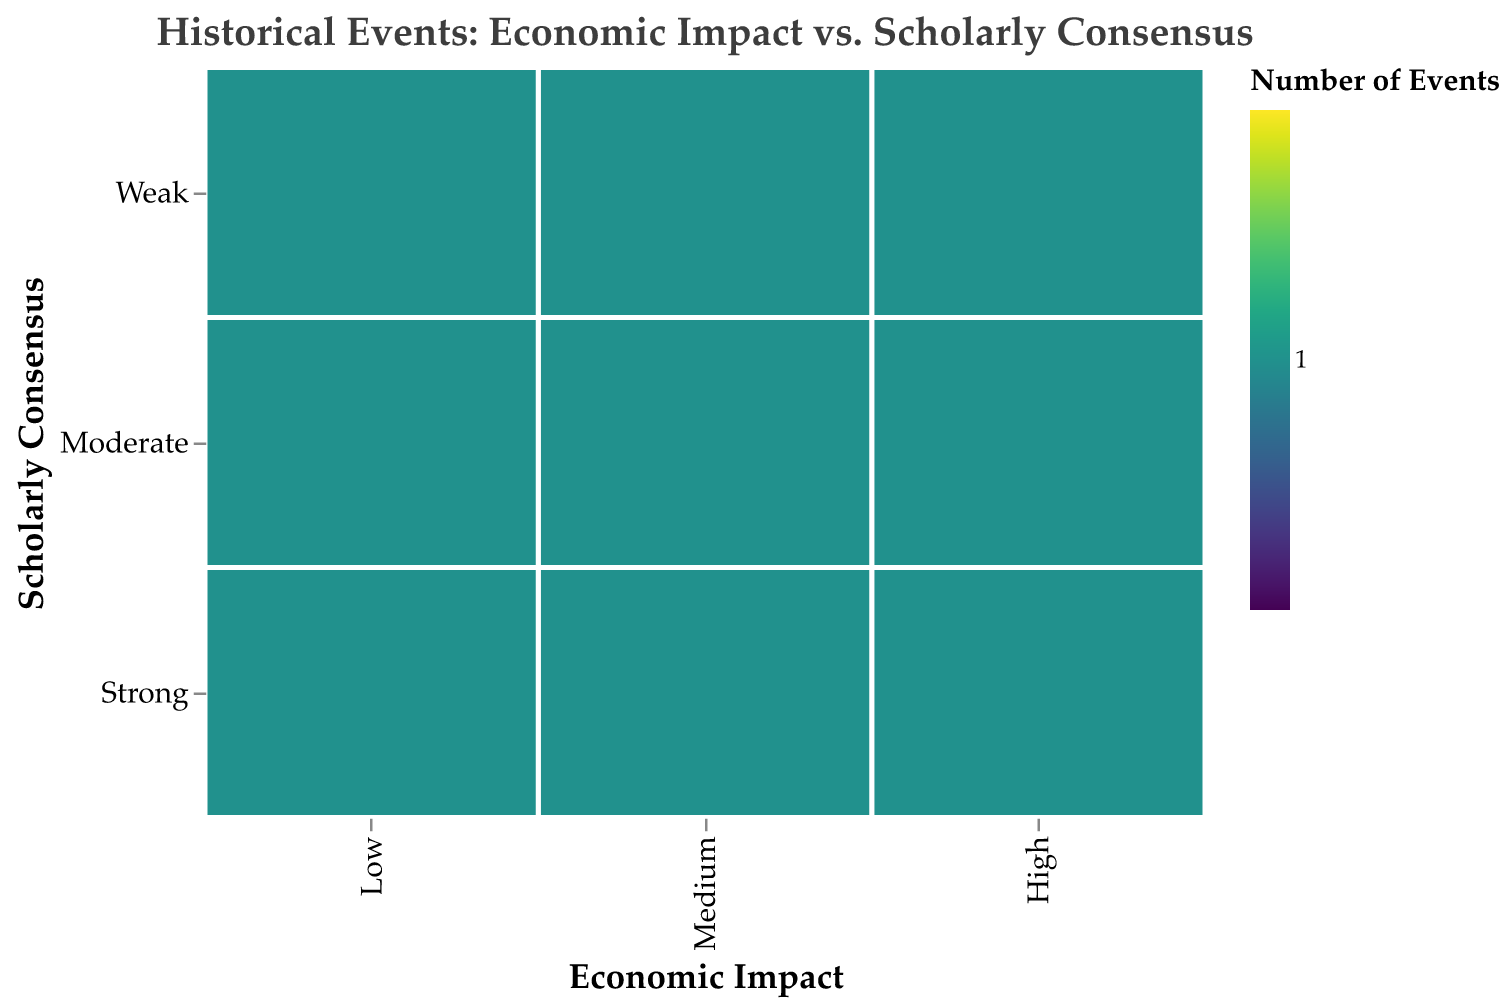What is the title of the figure? The title is usually located at the top of the figure and reads "Historical Events: Economic Impact vs. Scholarly Consensus" in this case.
Answer: Historical Events: Economic Impact vs. Scholarly Consensus How many events have a "High" economic impact? Count the number of boxes in the "High" category on the x-axis. There are four events listed.
Answer: 4 Which category of scholarly consensus has the highest representation in the "Medium" economic impact group? Look at the y-axis under the "Medium" economic impact and see which box covers the most area. Both "Strong" and "Moderate" have large areas, but "Moderate" has just one event listed.
Answer: Strong How many total events are there in the figure? Count all the individual events listed within their respective boxes. There are 10 events in total.
Answer: 10 Which event is categorized under "High" economic impact and "Weak" scholarly consensus? Find the intersecting box for "High" economic impact and "Weak" scholarly consensus and look at the tooltip information or label. The event listed is "Invention of the Internet".
Answer: Invention of the Internet How many events fall under a "Strong" scholarly consensus? Check the rows marked "Strong" for each economic impact category and add up the events. There are four events listed under "Strong".
Answer: 4 Compare the number of events with "Low" economic impact to those with "High" economic impact. Which has more events? Count the events under "Low" and "High" economic impacts and compare. There are three events under "Low" and four under "High". So, "High" has more events.
Answer: High Are there any events with "Low" economic impact and "Strong" scholarly consensus? If yes, name the event. Look at the intersection of "Low" economic impact and "Strong" scholarly consensus. The event listed there is "Black Death".
Answer: Black Death Which category of economic impact has the least representation in the "Weak" scholarly consensus group? Look at the row labeled "Weak" and see which economic impact category has the smallest area or fewest number. The "Low" economic impact category has the least representation with only one event.
Answer: Low 